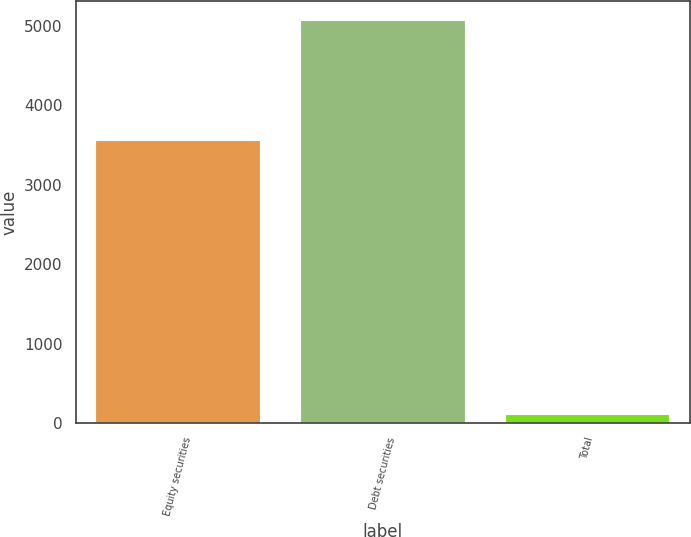Convert chart to OTSL. <chart><loc_0><loc_0><loc_500><loc_500><bar_chart><fcel>Equity securities<fcel>Debt securities<fcel>Total<nl><fcel>3550<fcel>5065<fcel>100<nl></chart> 